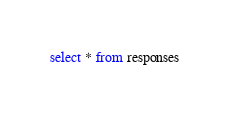<code> <loc_0><loc_0><loc_500><loc_500><_SQL_>select * from responses</code> 